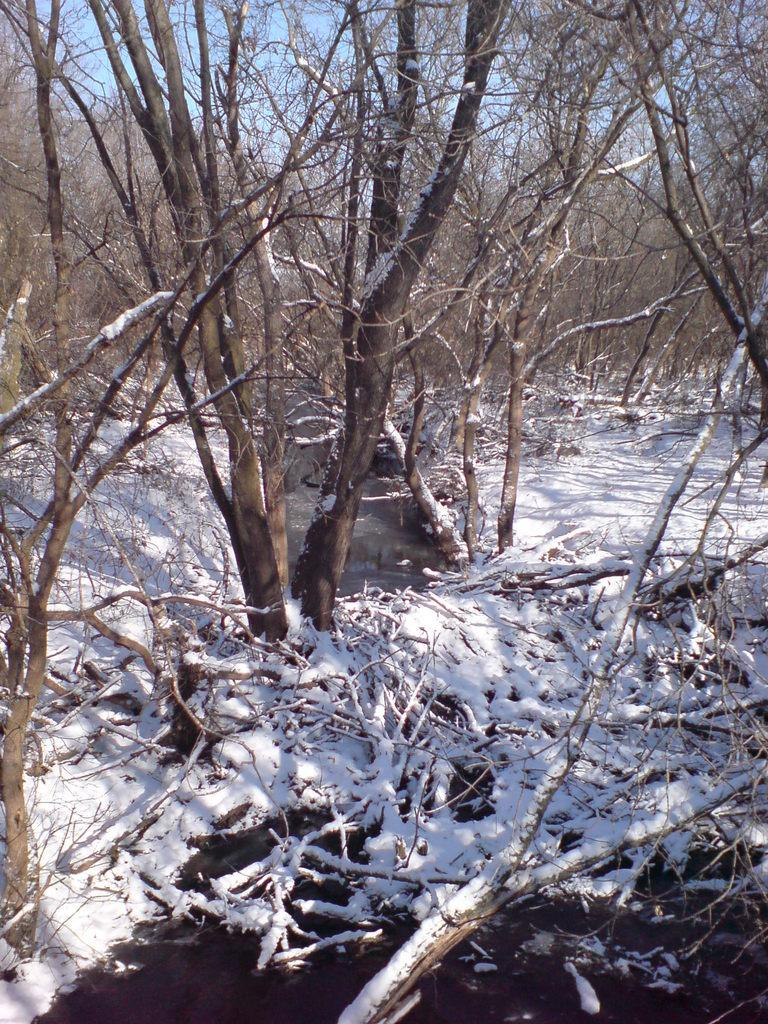What type of vegetation can be seen in the image? There are trees in the image. What is covering the land in the image? There is snow on the land in the image. What type of chain can be seen hanging from the trees in the image? There is no chain present in the image; it only features trees and snow-covered land. What type of rice is being cooked in the image? There is no rice or cooking activity present in the image. 